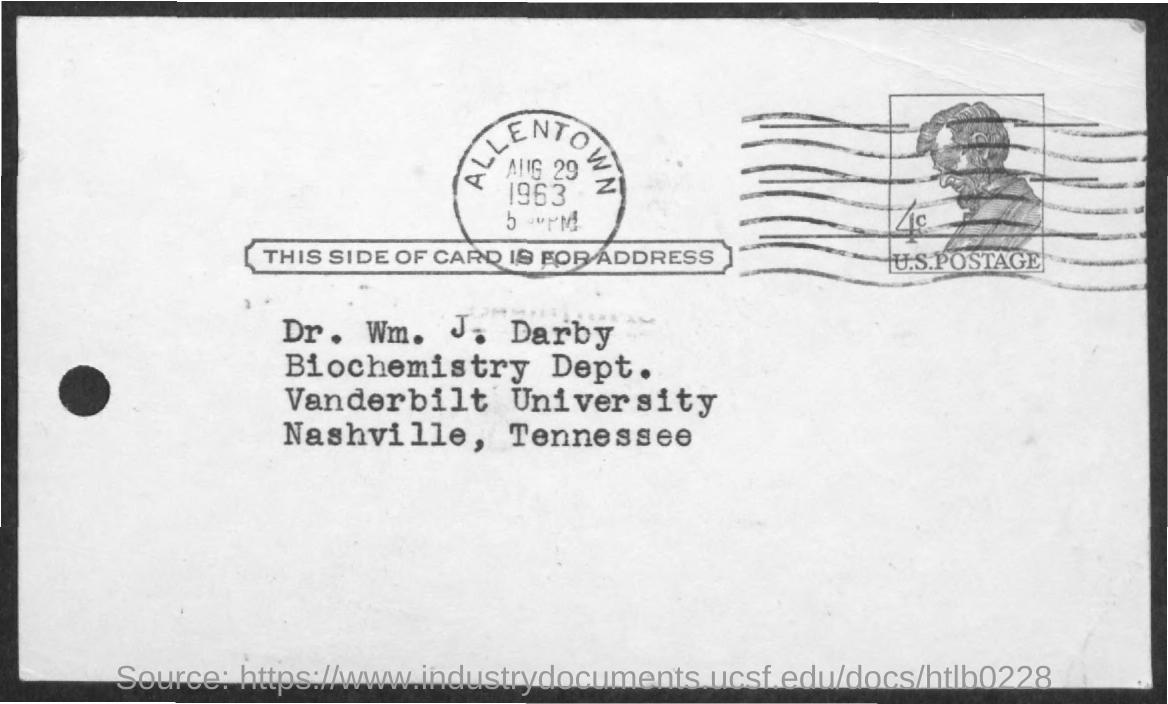Point out several critical features in this image. The date stamped on the postcard is Aug 29. Dr. William J. Darby belongs to the Biochemistry Department. The name of the person given in the address is Dr. Wm. J. Darby. 